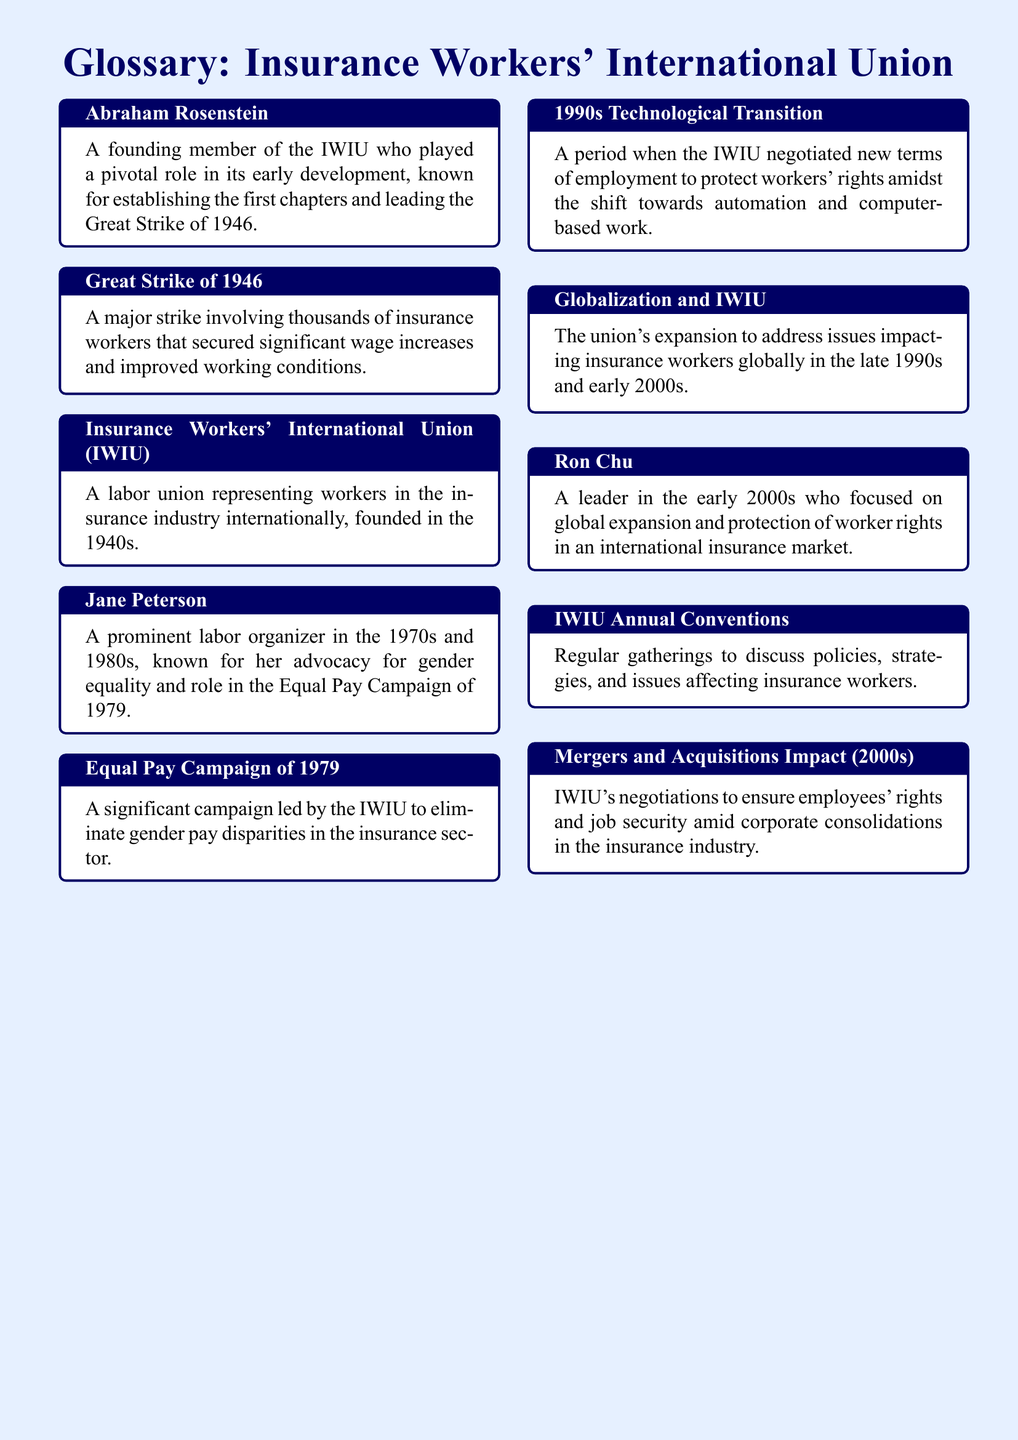What was the Great Strike of 1946? The Great Strike of 1946 was a major strike involving thousands of insurance workers that secured significant wage increases and improved working conditions.
Answer: Major strike Who was Abraham Rosenstein? Abraham Rosenstein was a founding member of the IWIU who played a pivotal role in its early development.
Answer: Founding member What campaign did Jane Peterson lead in 1979? Jane Peterson was known for her role in the Equal Pay Campaign of 1979.
Answer: Equal Pay Campaign What significant transition occurred in the 1990s? The 1990s Technological Transition was a period when the IWIU negotiated new terms of employment amidst the shift towards automation.
Answer: Technological Transition What did the IWIU address in the late 1990s? The IWIU expanded to address issues impacting insurance workers globally in the late 1990s.
Answer: Globalization Who was a leader in the early 2000s focusing on global expansion? Ron Chu was a leader in the early 2000s who focused on global expansion and protection of worker rights.
Answer: Ron Chu What type of gatherings does the IWIU hold? The IWIU holds annual conventions to discuss policies and strategies affecting insurance workers.
Answer: Annual Conventions What was a key focus during the mergers and acquisitions in the 2000s? The IWIU negotiated to ensure employees' rights and job security amid corporate consolidations.
Answer: Employees' rights 